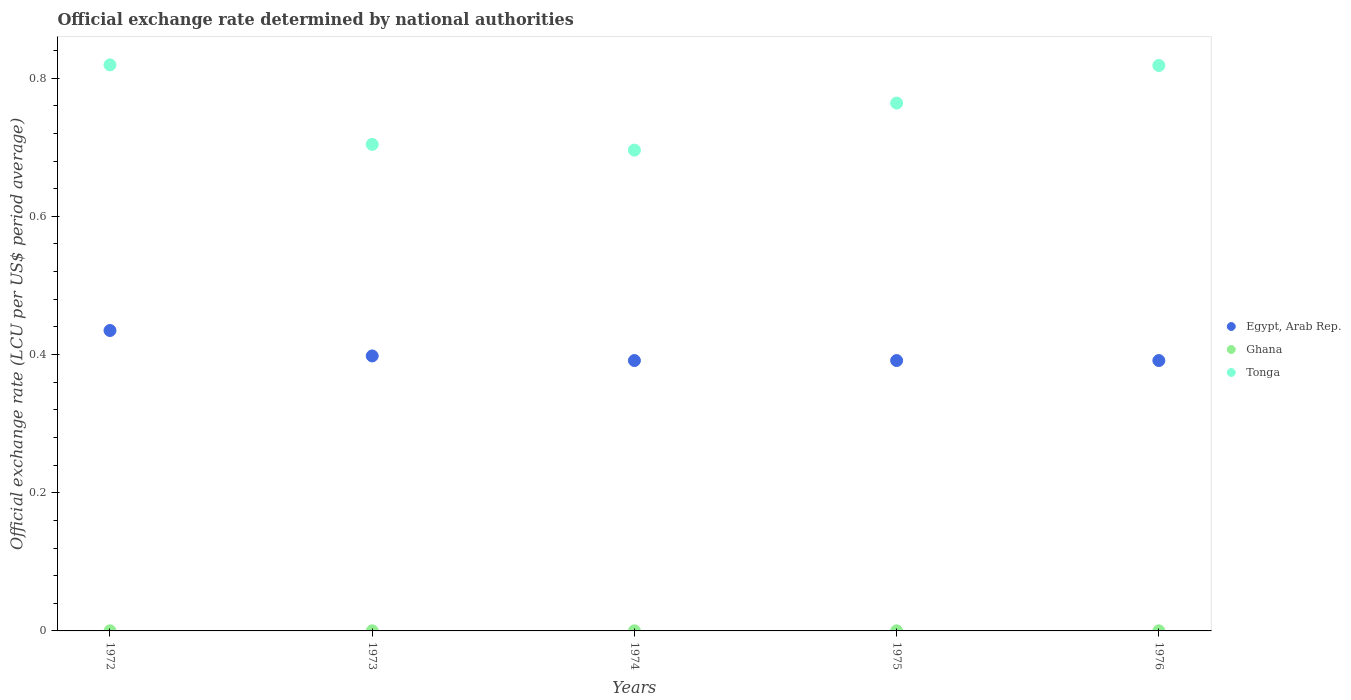What is the official exchange rate in Egypt, Arab Rep. in 1974?
Offer a very short reply. 0.39. Across all years, what is the maximum official exchange rate in Egypt, Arab Rep.?
Provide a succinct answer. 0.43. Across all years, what is the minimum official exchange rate in Ghana?
Offer a very short reply. 0. In which year was the official exchange rate in Egypt, Arab Rep. maximum?
Make the answer very short. 1972. In which year was the official exchange rate in Tonga minimum?
Offer a very short reply. 1974. What is the total official exchange rate in Ghana in the graph?
Your response must be concise. 0. What is the difference between the official exchange rate in Ghana in 1973 and that in 1976?
Provide a succinct answer. 1.4991935483870007e-6. What is the difference between the official exchange rate in Tonga in 1975 and the official exchange rate in Ghana in 1976?
Keep it short and to the point. 0.76. What is the average official exchange rate in Egypt, Arab Rep. per year?
Your answer should be very brief. 0.4. In the year 1976, what is the difference between the official exchange rate in Egypt, Arab Rep. and official exchange rate in Ghana?
Your answer should be very brief. 0.39. Is the official exchange rate in Tonga in 1973 less than that in 1974?
Keep it short and to the point. No. What is the difference between the highest and the second highest official exchange rate in Egypt, Arab Rep.?
Ensure brevity in your answer.  0.04. What is the difference between the highest and the lowest official exchange rate in Ghana?
Provide a succinct answer. 1.8329306899641002e-5. In how many years, is the official exchange rate in Egypt, Arab Rep. greater than the average official exchange rate in Egypt, Arab Rep. taken over all years?
Your answer should be compact. 1. Is the sum of the official exchange rate in Ghana in 1972 and 1976 greater than the maximum official exchange rate in Tonga across all years?
Offer a very short reply. No. Is it the case that in every year, the sum of the official exchange rate in Egypt, Arab Rep. and official exchange rate in Tonga  is greater than the official exchange rate in Ghana?
Your response must be concise. Yes. Does the official exchange rate in Egypt, Arab Rep. monotonically increase over the years?
Give a very brief answer. No. Is the official exchange rate in Ghana strictly greater than the official exchange rate in Egypt, Arab Rep. over the years?
Offer a terse response. No. Is the official exchange rate in Egypt, Arab Rep. strictly less than the official exchange rate in Tonga over the years?
Keep it short and to the point. Yes. How many years are there in the graph?
Your answer should be compact. 5. Does the graph contain any zero values?
Provide a succinct answer. No. How many legend labels are there?
Your answer should be compact. 3. What is the title of the graph?
Make the answer very short. Official exchange rate determined by national authorities. Does "Zimbabwe" appear as one of the legend labels in the graph?
Offer a terse response. No. What is the label or title of the Y-axis?
Keep it short and to the point. Official exchange rate (LCU per US$ period average). What is the Official exchange rate (LCU per US$ period average) of Egypt, Arab Rep. in 1972?
Your answer should be very brief. 0.43. What is the Official exchange rate (LCU per US$ period average) of Ghana in 1972?
Ensure brevity in your answer.  0. What is the Official exchange rate (LCU per US$ period average) in Tonga in 1972?
Offer a terse response. 0.82. What is the Official exchange rate (LCU per US$ period average) of Egypt, Arab Rep. in 1973?
Keep it short and to the point. 0.4. What is the Official exchange rate (LCU per US$ period average) of Ghana in 1973?
Your answer should be very brief. 0. What is the Official exchange rate (LCU per US$ period average) in Tonga in 1973?
Give a very brief answer. 0.7. What is the Official exchange rate (LCU per US$ period average) of Egypt, Arab Rep. in 1974?
Keep it short and to the point. 0.39. What is the Official exchange rate (LCU per US$ period average) in Ghana in 1974?
Make the answer very short. 0. What is the Official exchange rate (LCU per US$ period average) in Tonga in 1974?
Your answer should be very brief. 0.7. What is the Official exchange rate (LCU per US$ period average) in Egypt, Arab Rep. in 1975?
Your answer should be compact. 0.39. What is the Official exchange rate (LCU per US$ period average) of Ghana in 1975?
Provide a short and direct response. 0. What is the Official exchange rate (LCU per US$ period average) in Tonga in 1975?
Give a very brief answer. 0.76. What is the Official exchange rate (LCU per US$ period average) of Egypt, Arab Rep. in 1976?
Give a very brief answer. 0.39. What is the Official exchange rate (LCU per US$ period average) of Ghana in 1976?
Offer a terse response. 0. What is the Official exchange rate (LCU per US$ period average) in Tonga in 1976?
Ensure brevity in your answer.  0.82. Across all years, what is the maximum Official exchange rate (LCU per US$ period average) in Egypt, Arab Rep.?
Give a very brief answer. 0.43. Across all years, what is the maximum Official exchange rate (LCU per US$ period average) in Ghana?
Provide a succinct answer. 0. Across all years, what is the maximum Official exchange rate (LCU per US$ period average) in Tonga?
Offer a terse response. 0.82. Across all years, what is the minimum Official exchange rate (LCU per US$ period average) of Egypt, Arab Rep.?
Your answer should be very brief. 0.39. Across all years, what is the minimum Official exchange rate (LCU per US$ period average) of Ghana?
Give a very brief answer. 0. Across all years, what is the minimum Official exchange rate (LCU per US$ period average) in Tonga?
Make the answer very short. 0.7. What is the total Official exchange rate (LCU per US$ period average) of Egypt, Arab Rep. in the graph?
Make the answer very short. 2.01. What is the total Official exchange rate (LCU per US$ period average) in Ghana in the graph?
Ensure brevity in your answer.  0. What is the total Official exchange rate (LCU per US$ period average) of Tonga in the graph?
Your answer should be very brief. 3.8. What is the difference between the Official exchange rate (LCU per US$ period average) in Egypt, Arab Rep. in 1972 and that in 1973?
Give a very brief answer. 0.04. What is the difference between the Official exchange rate (LCU per US$ period average) in Tonga in 1972 and that in 1973?
Your response must be concise. 0.12. What is the difference between the Official exchange rate (LCU per US$ period average) in Egypt, Arab Rep. in 1972 and that in 1974?
Provide a succinct answer. 0.04. What is the difference between the Official exchange rate (LCU per US$ period average) in Tonga in 1972 and that in 1974?
Ensure brevity in your answer.  0.12. What is the difference between the Official exchange rate (LCU per US$ period average) in Egypt, Arab Rep. in 1972 and that in 1975?
Offer a very short reply. 0.04. What is the difference between the Official exchange rate (LCU per US$ period average) of Tonga in 1972 and that in 1975?
Your answer should be compact. 0.06. What is the difference between the Official exchange rate (LCU per US$ period average) of Egypt, Arab Rep. in 1972 and that in 1976?
Provide a succinct answer. 0.04. What is the difference between the Official exchange rate (LCU per US$ period average) in Tonga in 1972 and that in 1976?
Keep it short and to the point. 0. What is the difference between the Official exchange rate (LCU per US$ period average) of Egypt, Arab Rep. in 1973 and that in 1974?
Your answer should be very brief. 0.01. What is the difference between the Official exchange rate (LCU per US$ period average) in Tonga in 1973 and that in 1974?
Offer a very short reply. 0.01. What is the difference between the Official exchange rate (LCU per US$ period average) of Egypt, Arab Rep. in 1973 and that in 1975?
Ensure brevity in your answer.  0.01. What is the difference between the Official exchange rate (LCU per US$ period average) in Ghana in 1973 and that in 1975?
Offer a very short reply. 0. What is the difference between the Official exchange rate (LCU per US$ period average) in Tonga in 1973 and that in 1975?
Your answer should be very brief. -0.06. What is the difference between the Official exchange rate (LCU per US$ period average) in Egypt, Arab Rep. in 1973 and that in 1976?
Keep it short and to the point. 0.01. What is the difference between the Official exchange rate (LCU per US$ period average) in Ghana in 1973 and that in 1976?
Offer a very short reply. 0. What is the difference between the Official exchange rate (LCU per US$ period average) of Tonga in 1973 and that in 1976?
Provide a succinct answer. -0.11. What is the difference between the Official exchange rate (LCU per US$ period average) in Ghana in 1974 and that in 1975?
Your answer should be very brief. 0. What is the difference between the Official exchange rate (LCU per US$ period average) in Tonga in 1974 and that in 1975?
Provide a succinct answer. -0.07. What is the difference between the Official exchange rate (LCU per US$ period average) in Egypt, Arab Rep. in 1974 and that in 1976?
Your answer should be very brief. 0. What is the difference between the Official exchange rate (LCU per US$ period average) in Tonga in 1974 and that in 1976?
Give a very brief answer. -0.12. What is the difference between the Official exchange rate (LCU per US$ period average) in Egypt, Arab Rep. in 1975 and that in 1976?
Keep it short and to the point. 0. What is the difference between the Official exchange rate (LCU per US$ period average) of Tonga in 1975 and that in 1976?
Offer a terse response. -0.05. What is the difference between the Official exchange rate (LCU per US$ period average) of Egypt, Arab Rep. in 1972 and the Official exchange rate (LCU per US$ period average) of Ghana in 1973?
Offer a terse response. 0.43. What is the difference between the Official exchange rate (LCU per US$ period average) in Egypt, Arab Rep. in 1972 and the Official exchange rate (LCU per US$ period average) in Tonga in 1973?
Your response must be concise. -0.27. What is the difference between the Official exchange rate (LCU per US$ period average) in Ghana in 1972 and the Official exchange rate (LCU per US$ period average) in Tonga in 1973?
Offer a terse response. -0.7. What is the difference between the Official exchange rate (LCU per US$ period average) of Egypt, Arab Rep. in 1972 and the Official exchange rate (LCU per US$ period average) of Ghana in 1974?
Your response must be concise. 0.43. What is the difference between the Official exchange rate (LCU per US$ period average) in Egypt, Arab Rep. in 1972 and the Official exchange rate (LCU per US$ period average) in Tonga in 1974?
Keep it short and to the point. -0.26. What is the difference between the Official exchange rate (LCU per US$ period average) of Ghana in 1972 and the Official exchange rate (LCU per US$ period average) of Tonga in 1974?
Make the answer very short. -0.7. What is the difference between the Official exchange rate (LCU per US$ period average) in Egypt, Arab Rep. in 1972 and the Official exchange rate (LCU per US$ period average) in Ghana in 1975?
Ensure brevity in your answer.  0.43. What is the difference between the Official exchange rate (LCU per US$ period average) of Egypt, Arab Rep. in 1972 and the Official exchange rate (LCU per US$ period average) of Tonga in 1975?
Give a very brief answer. -0.33. What is the difference between the Official exchange rate (LCU per US$ period average) in Ghana in 1972 and the Official exchange rate (LCU per US$ period average) in Tonga in 1975?
Keep it short and to the point. -0.76. What is the difference between the Official exchange rate (LCU per US$ period average) of Egypt, Arab Rep. in 1972 and the Official exchange rate (LCU per US$ period average) of Ghana in 1976?
Give a very brief answer. 0.43. What is the difference between the Official exchange rate (LCU per US$ period average) of Egypt, Arab Rep. in 1972 and the Official exchange rate (LCU per US$ period average) of Tonga in 1976?
Make the answer very short. -0.38. What is the difference between the Official exchange rate (LCU per US$ period average) of Ghana in 1972 and the Official exchange rate (LCU per US$ period average) of Tonga in 1976?
Give a very brief answer. -0.82. What is the difference between the Official exchange rate (LCU per US$ period average) of Egypt, Arab Rep. in 1973 and the Official exchange rate (LCU per US$ period average) of Ghana in 1974?
Your answer should be very brief. 0.4. What is the difference between the Official exchange rate (LCU per US$ period average) in Egypt, Arab Rep. in 1973 and the Official exchange rate (LCU per US$ period average) in Tonga in 1974?
Provide a short and direct response. -0.3. What is the difference between the Official exchange rate (LCU per US$ period average) in Ghana in 1973 and the Official exchange rate (LCU per US$ period average) in Tonga in 1974?
Your response must be concise. -0.7. What is the difference between the Official exchange rate (LCU per US$ period average) in Egypt, Arab Rep. in 1973 and the Official exchange rate (LCU per US$ period average) in Ghana in 1975?
Ensure brevity in your answer.  0.4. What is the difference between the Official exchange rate (LCU per US$ period average) of Egypt, Arab Rep. in 1973 and the Official exchange rate (LCU per US$ period average) of Tonga in 1975?
Your response must be concise. -0.37. What is the difference between the Official exchange rate (LCU per US$ period average) in Ghana in 1973 and the Official exchange rate (LCU per US$ period average) in Tonga in 1975?
Provide a succinct answer. -0.76. What is the difference between the Official exchange rate (LCU per US$ period average) in Egypt, Arab Rep. in 1973 and the Official exchange rate (LCU per US$ period average) in Ghana in 1976?
Give a very brief answer. 0.4. What is the difference between the Official exchange rate (LCU per US$ period average) of Egypt, Arab Rep. in 1973 and the Official exchange rate (LCU per US$ period average) of Tonga in 1976?
Your answer should be very brief. -0.42. What is the difference between the Official exchange rate (LCU per US$ period average) of Ghana in 1973 and the Official exchange rate (LCU per US$ period average) of Tonga in 1976?
Keep it short and to the point. -0.82. What is the difference between the Official exchange rate (LCU per US$ period average) in Egypt, Arab Rep. in 1974 and the Official exchange rate (LCU per US$ period average) in Ghana in 1975?
Your answer should be compact. 0.39. What is the difference between the Official exchange rate (LCU per US$ period average) of Egypt, Arab Rep. in 1974 and the Official exchange rate (LCU per US$ period average) of Tonga in 1975?
Offer a terse response. -0.37. What is the difference between the Official exchange rate (LCU per US$ period average) in Ghana in 1974 and the Official exchange rate (LCU per US$ period average) in Tonga in 1975?
Offer a very short reply. -0.76. What is the difference between the Official exchange rate (LCU per US$ period average) in Egypt, Arab Rep. in 1974 and the Official exchange rate (LCU per US$ period average) in Ghana in 1976?
Your response must be concise. 0.39. What is the difference between the Official exchange rate (LCU per US$ period average) in Egypt, Arab Rep. in 1974 and the Official exchange rate (LCU per US$ period average) in Tonga in 1976?
Provide a short and direct response. -0.43. What is the difference between the Official exchange rate (LCU per US$ period average) of Ghana in 1974 and the Official exchange rate (LCU per US$ period average) of Tonga in 1976?
Provide a short and direct response. -0.82. What is the difference between the Official exchange rate (LCU per US$ period average) in Egypt, Arab Rep. in 1975 and the Official exchange rate (LCU per US$ period average) in Ghana in 1976?
Offer a terse response. 0.39. What is the difference between the Official exchange rate (LCU per US$ period average) of Egypt, Arab Rep. in 1975 and the Official exchange rate (LCU per US$ period average) of Tonga in 1976?
Keep it short and to the point. -0.43. What is the difference between the Official exchange rate (LCU per US$ period average) of Ghana in 1975 and the Official exchange rate (LCU per US$ period average) of Tonga in 1976?
Provide a succinct answer. -0.82. What is the average Official exchange rate (LCU per US$ period average) in Egypt, Arab Rep. per year?
Your response must be concise. 0.4. What is the average Official exchange rate (LCU per US$ period average) of Ghana per year?
Give a very brief answer. 0. What is the average Official exchange rate (LCU per US$ period average) in Tonga per year?
Offer a very short reply. 0.76. In the year 1972, what is the difference between the Official exchange rate (LCU per US$ period average) in Egypt, Arab Rep. and Official exchange rate (LCU per US$ period average) in Ghana?
Provide a succinct answer. 0.43. In the year 1972, what is the difference between the Official exchange rate (LCU per US$ period average) of Egypt, Arab Rep. and Official exchange rate (LCU per US$ period average) of Tonga?
Make the answer very short. -0.38. In the year 1972, what is the difference between the Official exchange rate (LCU per US$ period average) in Ghana and Official exchange rate (LCU per US$ period average) in Tonga?
Provide a short and direct response. -0.82. In the year 1973, what is the difference between the Official exchange rate (LCU per US$ period average) in Egypt, Arab Rep. and Official exchange rate (LCU per US$ period average) in Ghana?
Your response must be concise. 0.4. In the year 1973, what is the difference between the Official exchange rate (LCU per US$ period average) of Egypt, Arab Rep. and Official exchange rate (LCU per US$ period average) of Tonga?
Offer a very short reply. -0.31. In the year 1973, what is the difference between the Official exchange rate (LCU per US$ period average) in Ghana and Official exchange rate (LCU per US$ period average) in Tonga?
Offer a very short reply. -0.7. In the year 1974, what is the difference between the Official exchange rate (LCU per US$ period average) in Egypt, Arab Rep. and Official exchange rate (LCU per US$ period average) in Ghana?
Keep it short and to the point. 0.39. In the year 1974, what is the difference between the Official exchange rate (LCU per US$ period average) of Egypt, Arab Rep. and Official exchange rate (LCU per US$ period average) of Tonga?
Your answer should be very brief. -0.3. In the year 1974, what is the difference between the Official exchange rate (LCU per US$ period average) in Ghana and Official exchange rate (LCU per US$ period average) in Tonga?
Ensure brevity in your answer.  -0.7. In the year 1975, what is the difference between the Official exchange rate (LCU per US$ period average) of Egypt, Arab Rep. and Official exchange rate (LCU per US$ period average) of Ghana?
Give a very brief answer. 0.39. In the year 1975, what is the difference between the Official exchange rate (LCU per US$ period average) in Egypt, Arab Rep. and Official exchange rate (LCU per US$ period average) in Tonga?
Offer a terse response. -0.37. In the year 1975, what is the difference between the Official exchange rate (LCU per US$ period average) of Ghana and Official exchange rate (LCU per US$ period average) of Tonga?
Give a very brief answer. -0.76. In the year 1976, what is the difference between the Official exchange rate (LCU per US$ period average) in Egypt, Arab Rep. and Official exchange rate (LCU per US$ period average) in Ghana?
Keep it short and to the point. 0.39. In the year 1976, what is the difference between the Official exchange rate (LCU per US$ period average) of Egypt, Arab Rep. and Official exchange rate (LCU per US$ period average) of Tonga?
Your answer should be very brief. -0.43. In the year 1976, what is the difference between the Official exchange rate (LCU per US$ period average) in Ghana and Official exchange rate (LCU per US$ period average) in Tonga?
Your answer should be compact. -0.82. What is the ratio of the Official exchange rate (LCU per US$ period average) of Egypt, Arab Rep. in 1972 to that in 1973?
Keep it short and to the point. 1.09. What is the ratio of the Official exchange rate (LCU per US$ period average) in Ghana in 1972 to that in 1973?
Provide a short and direct response. 1.14. What is the ratio of the Official exchange rate (LCU per US$ period average) in Tonga in 1972 to that in 1973?
Provide a short and direct response. 1.16. What is the ratio of the Official exchange rate (LCU per US$ period average) in Egypt, Arab Rep. in 1972 to that in 1974?
Make the answer very short. 1.11. What is the ratio of the Official exchange rate (LCU per US$ period average) of Ghana in 1972 to that in 1974?
Give a very brief answer. 1.16. What is the ratio of the Official exchange rate (LCU per US$ period average) of Tonga in 1972 to that in 1974?
Your answer should be very brief. 1.18. What is the ratio of the Official exchange rate (LCU per US$ period average) of Ghana in 1972 to that in 1975?
Offer a terse response. 1.16. What is the ratio of the Official exchange rate (LCU per US$ period average) in Tonga in 1972 to that in 1975?
Provide a succinct answer. 1.07. What is the ratio of the Official exchange rate (LCU per US$ period average) of Egypt, Arab Rep. in 1972 to that in 1976?
Keep it short and to the point. 1.11. What is the ratio of the Official exchange rate (LCU per US$ period average) of Ghana in 1972 to that in 1976?
Ensure brevity in your answer.  1.16. What is the ratio of the Official exchange rate (LCU per US$ period average) in Tonga in 1972 to that in 1976?
Provide a succinct answer. 1. What is the ratio of the Official exchange rate (LCU per US$ period average) in Ghana in 1973 to that in 1974?
Your answer should be very brief. 1.01. What is the ratio of the Official exchange rate (LCU per US$ period average) of Tonga in 1973 to that in 1974?
Offer a very short reply. 1.01. What is the ratio of the Official exchange rate (LCU per US$ period average) in Tonga in 1973 to that in 1975?
Ensure brevity in your answer.  0.92. What is the ratio of the Official exchange rate (LCU per US$ period average) in Egypt, Arab Rep. in 1973 to that in 1976?
Ensure brevity in your answer.  1.02. What is the ratio of the Official exchange rate (LCU per US$ period average) of Tonga in 1973 to that in 1976?
Your answer should be compact. 0.86. What is the ratio of the Official exchange rate (LCU per US$ period average) in Tonga in 1974 to that in 1975?
Offer a terse response. 0.91. What is the ratio of the Official exchange rate (LCU per US$ period average) of Egypt, Arab Rep. in 1974 to that in 1976?
Give a very brief answer. 1. What is the ratio of the Official exchange rate (LCU per US$ period average) in Ghana in 1974 to that in 1976?
Provide a succinct answer. 1. What is the ratio of the Official exchange rate (LCU per US$ period average) in Tonga in 1974 to that in 1976?
Offer a terse response. 0.85. What is the ratio of the Official exchange rate (LCU per US$ period average) of Ghana in 1975 to that in 1976?
Offer a very short reply. 1. What is the ratio of the Official exchange rate (LCU per US$ period average) of Tonga in 1975 to that in 1976?
Make the answer very short. 0.93. What is the difference between the highest and the second highest Official exchange rate (LCU per US$ period average) of Egypt, Arab Rep.?
Make the answer very short. 0.04. What is the difference between the highest and the second highest Official exchange rate (LCU per US$ period average) of Tonga?
Offer a very short reply. 0. What is the difference between the highest and the lowest Official exchange rate (LCU per US$ period average) in Egypt, Arab Rep.?
Provide a succinct answer. 0.04. What is the difference between the highest and the lowest Official exchange rate (LCU per US$ period average) in Tonga?
Your answer should be very brief. 0.12. 